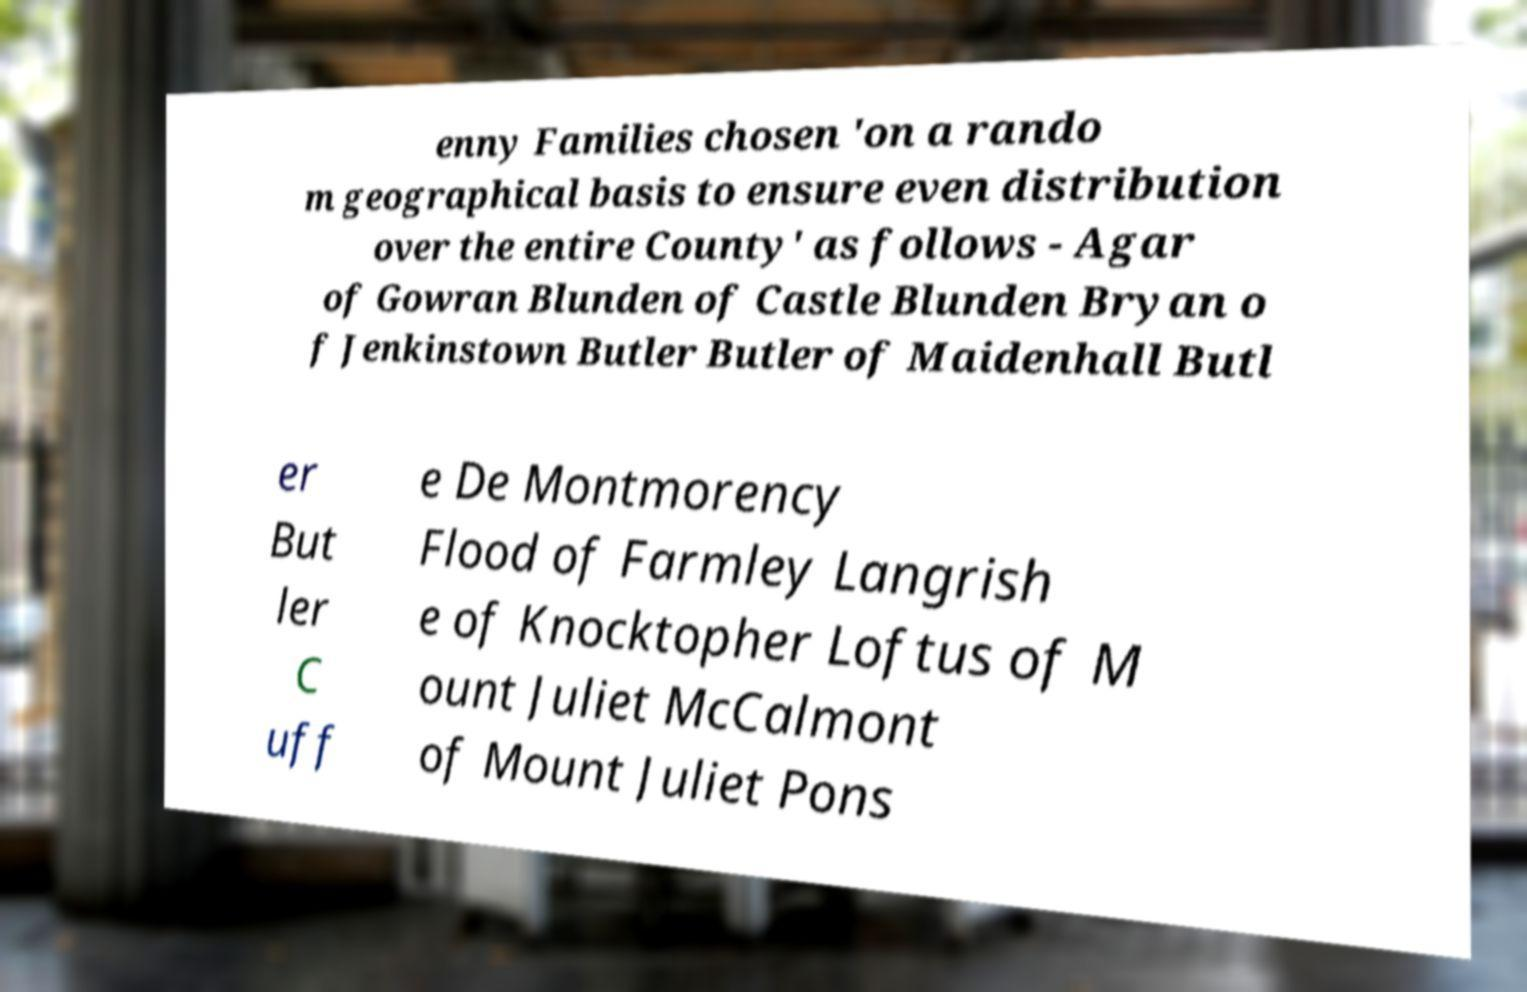Could you extract and type out the text from this image? enny Families chosen 'on a rando m geographical basis to ensure even distribution over the entire County' as follows - Agar of Gowran Blunden of Castle Blunden Bryan o f Jenkinstown Butler Butler of Maidenhall Butl er But ler C uff e De Montmorency Flood of Farmley Langrish e of Knocktopher Loftus of M ount Juliet McCalmont of Mount Juliet Pons 